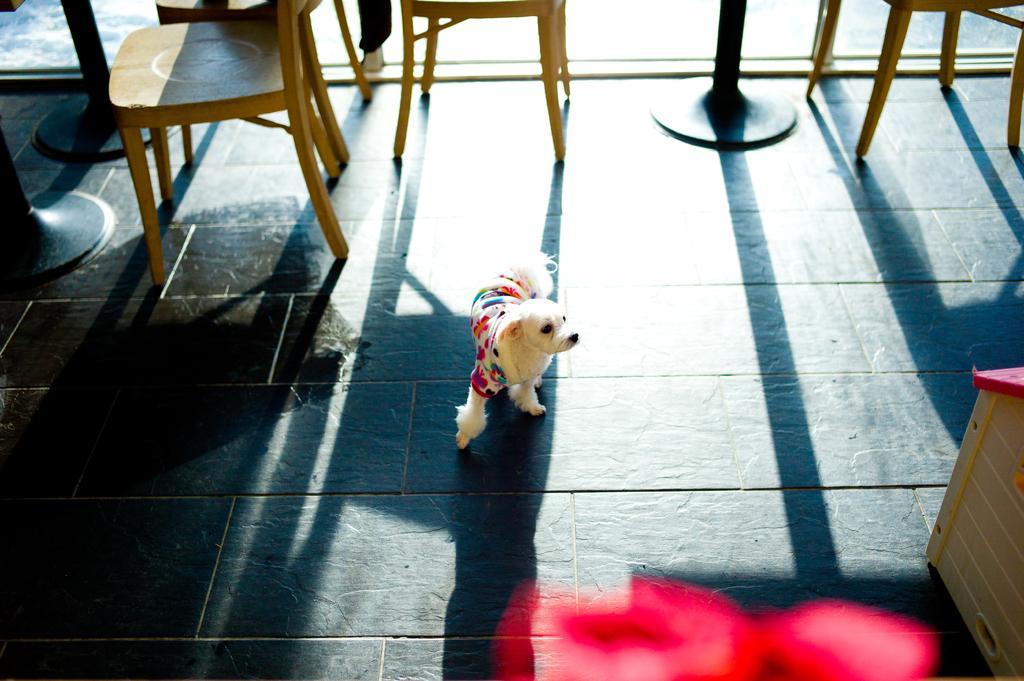In one or two sentences, can you explain what this image depicts? In this image i can see a dog wearing a dress on the floor. In the background i can see few chairs and few poles. 